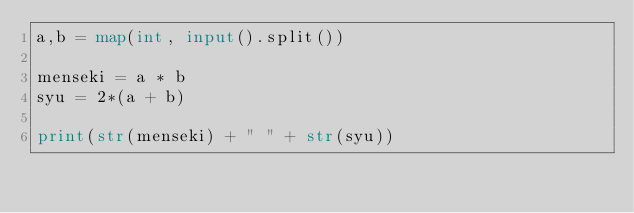<code> <loc_0><loc_0><loc_500><loc_500><_Python_>a,b = map(int, input().split())

menseki = a * b
syu = 2*(a + b)

print(str(menseki) + " " + str(syu))
</code> 